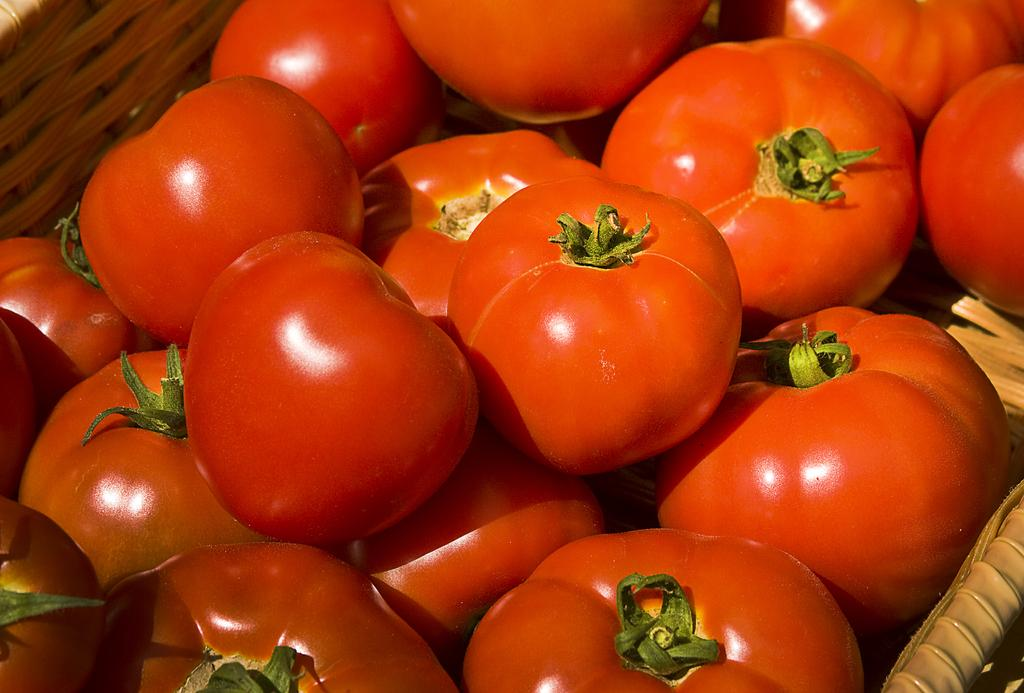What type of fruit is present in the image? There are tomatoes in the image. How are the tomatoes arranged or contained in the image? The tomatoes are in a basket. What type of donkey is carrying the tomatoes in the image? There is no donkey present in the image; the tomatoes are in a basket. How are the tomatoes being sorted in the image? The image does not show the tomatoes being sorted; they are simply in a basket. 